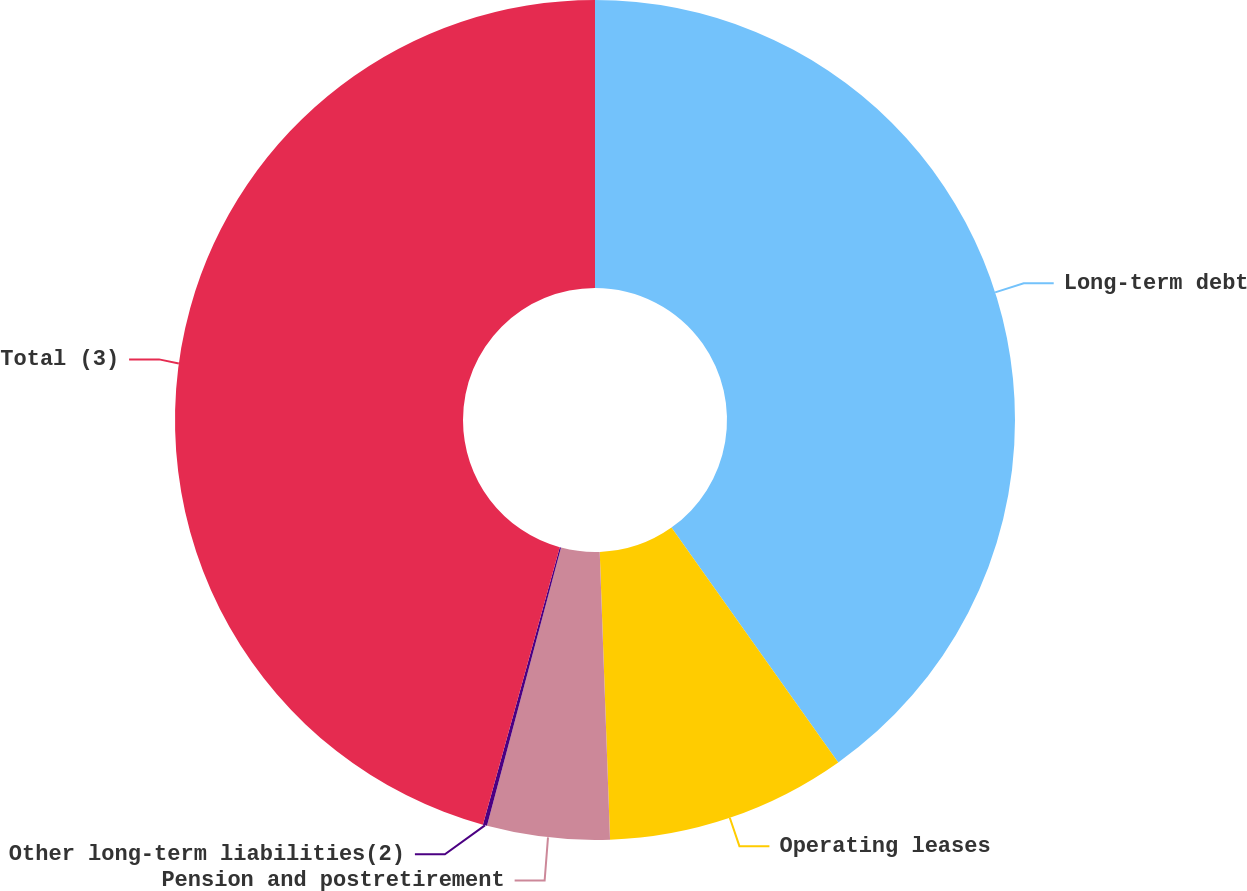<chart> <loc_0><loc_0><loc_500><loc_500><pie_chart><fcel>Long-term debt<fcel>Operating leases<fcel>Pension and postretirement<fcel>Other long-term liabilities(2)<fcel>Total (3)<nl><fcel>40.17%<fcel>9.26%<fcel>4.71%<fcel>0.16%<fcel>45.7%<nl></chart> 